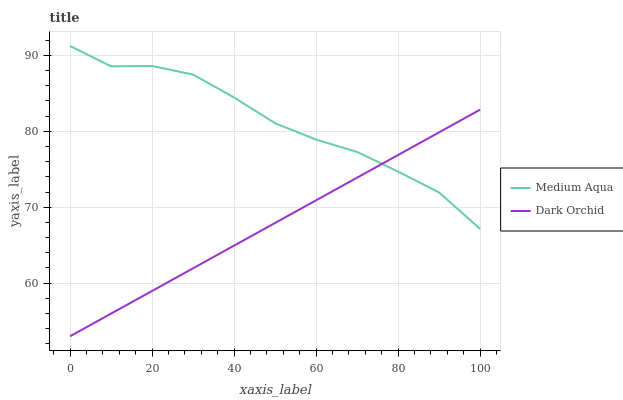Does Dark Orchid have the minimum area under the curve?
Answer yes or no. Yes. Does Medium Aqua have the maximum area under the curve?
Answer yes or no. Yes. Does Dark Orchid have the maximum area under the curve?
Answer yes or no. No. Is Dark Orchid the smoothest?
Answer yes or no. Yes. Is Medium Aqua the roughest?
Answer yes or no. Yes. Is Dark Orchid the roughest?
Answer yes or no. No. Does Dark Orchid have the lowest value?
Answer yes or no. Yes. Does Medium Aqua have the highest value?
Answer yes or no. Yes. Does Dark Orchid have the highest value?
Answer yes or no. No. Does Dark Orchid intersect Medium Aqua?
Answer yes or no. Yes. Is Dark Orchid less than Medium Aqua?
Answer yes or no. No. Is Dark Orchid greater than Medium Aqua?
Answer yes or no. No. 